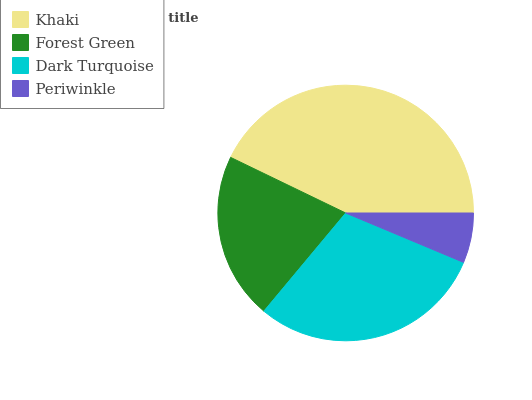Is Periwinkle the minimum?
Answer yes or no. Yes. Is Khaki the maximum?
Answer yes or no. Yes. Is Forest Green the minimum?
Answer yes or no. No. Is Forest Green the maximum?
Answer yes or no. No. Is Khaki greater than Forest Green?
Answer yes or no. Yes. Is Forest Green less than Khaki?
Answer yes or no. Yes. Is Forest Green greater than Khaki?
Answer yes or no. No. Is Khaki less than Forest Green?
Answer yes or no. No. Is Dark Turquoise the high median?
Answer yes or no. Yes. Is Forest Green the low median?
Answer yes or no. Yes. Is Forest Green the high median?
Answer yes or no. No. Is Periwinkle the low median?
Answer yes or no. No. 